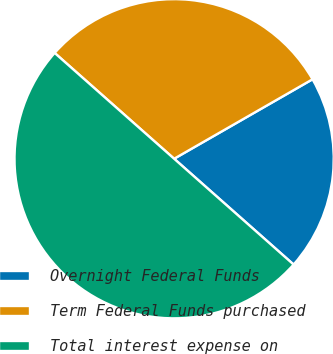<chart> <loc_0><loc_0><loc_500><loc_500><pie_chart><fcel>Overnight Federal Funds<fcel>Term Federal Funds purchased<fcel>Total interest expense on<nl><fcel>19.83%<fcel>30.17%<fcel>50.0%<nl></chart> 